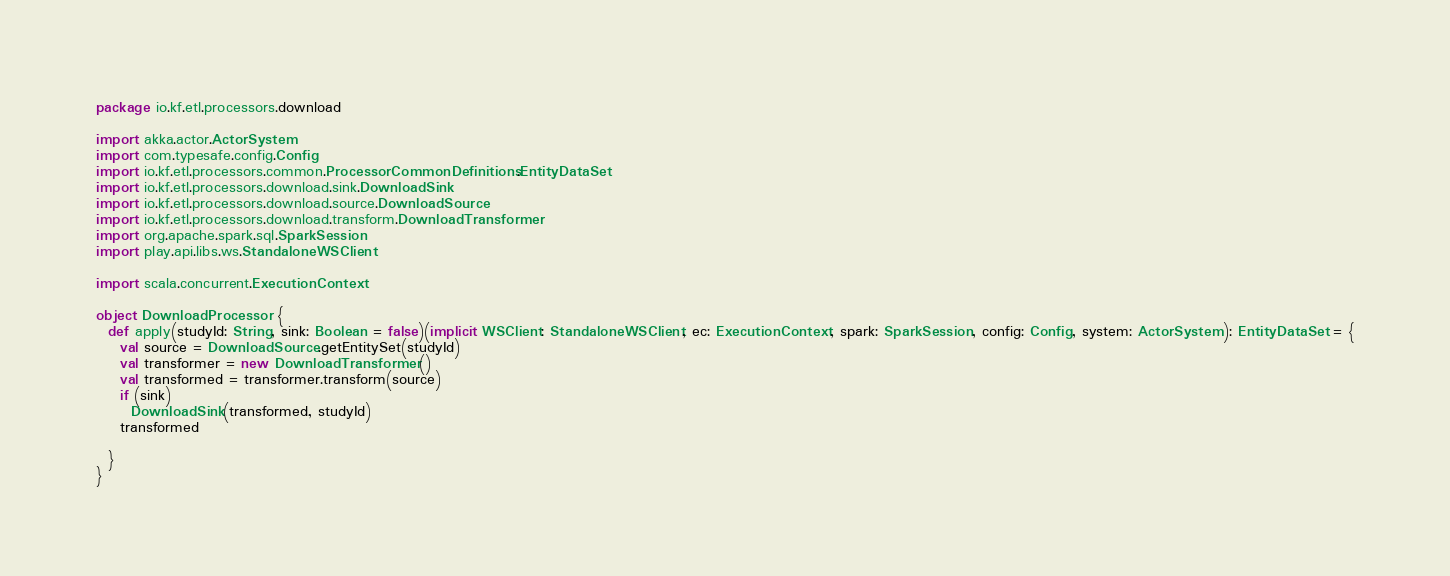Convert code to text. <code><loc_0><loc_0><loc_500><loc_500><_Scala_>package io.kf.etl.processors.download

import akka.actor.ActorSystem
import com.typesafe.config.Config
import io.kf.etl.processors.common.ProcessorCommonDefinitions.EntityDataSet
import io.kf.etl.processors.download.sink.DownloadSink
import io.kf.etl.processors.download.source.DownloadSource
import io.kf.etl.processors.download.transform.DownloadTransformer
import org.apache.spark.sql.SparkSession
import play.api.libs.ws.StandaloneWSClient

import scala.concurrent.ExecutionContext

object DownloadProcessor {
  def apply(studyId: String, sink: Boolean = false)(implicit WSClient: StandaloneWSClient, ec: ExecutionContext, spark: SparkSession, config: Config, system: ActorSystem): EntityDataSet = {
    val source = DownloadSource.getEntitySet(studyId)
    val transformer = new DownloadTransformer()
    val transformed = transformer.transform(source)
    if (sink)
      DownloadSink(transformed, studyId)
    transformed

  }
}</code> 